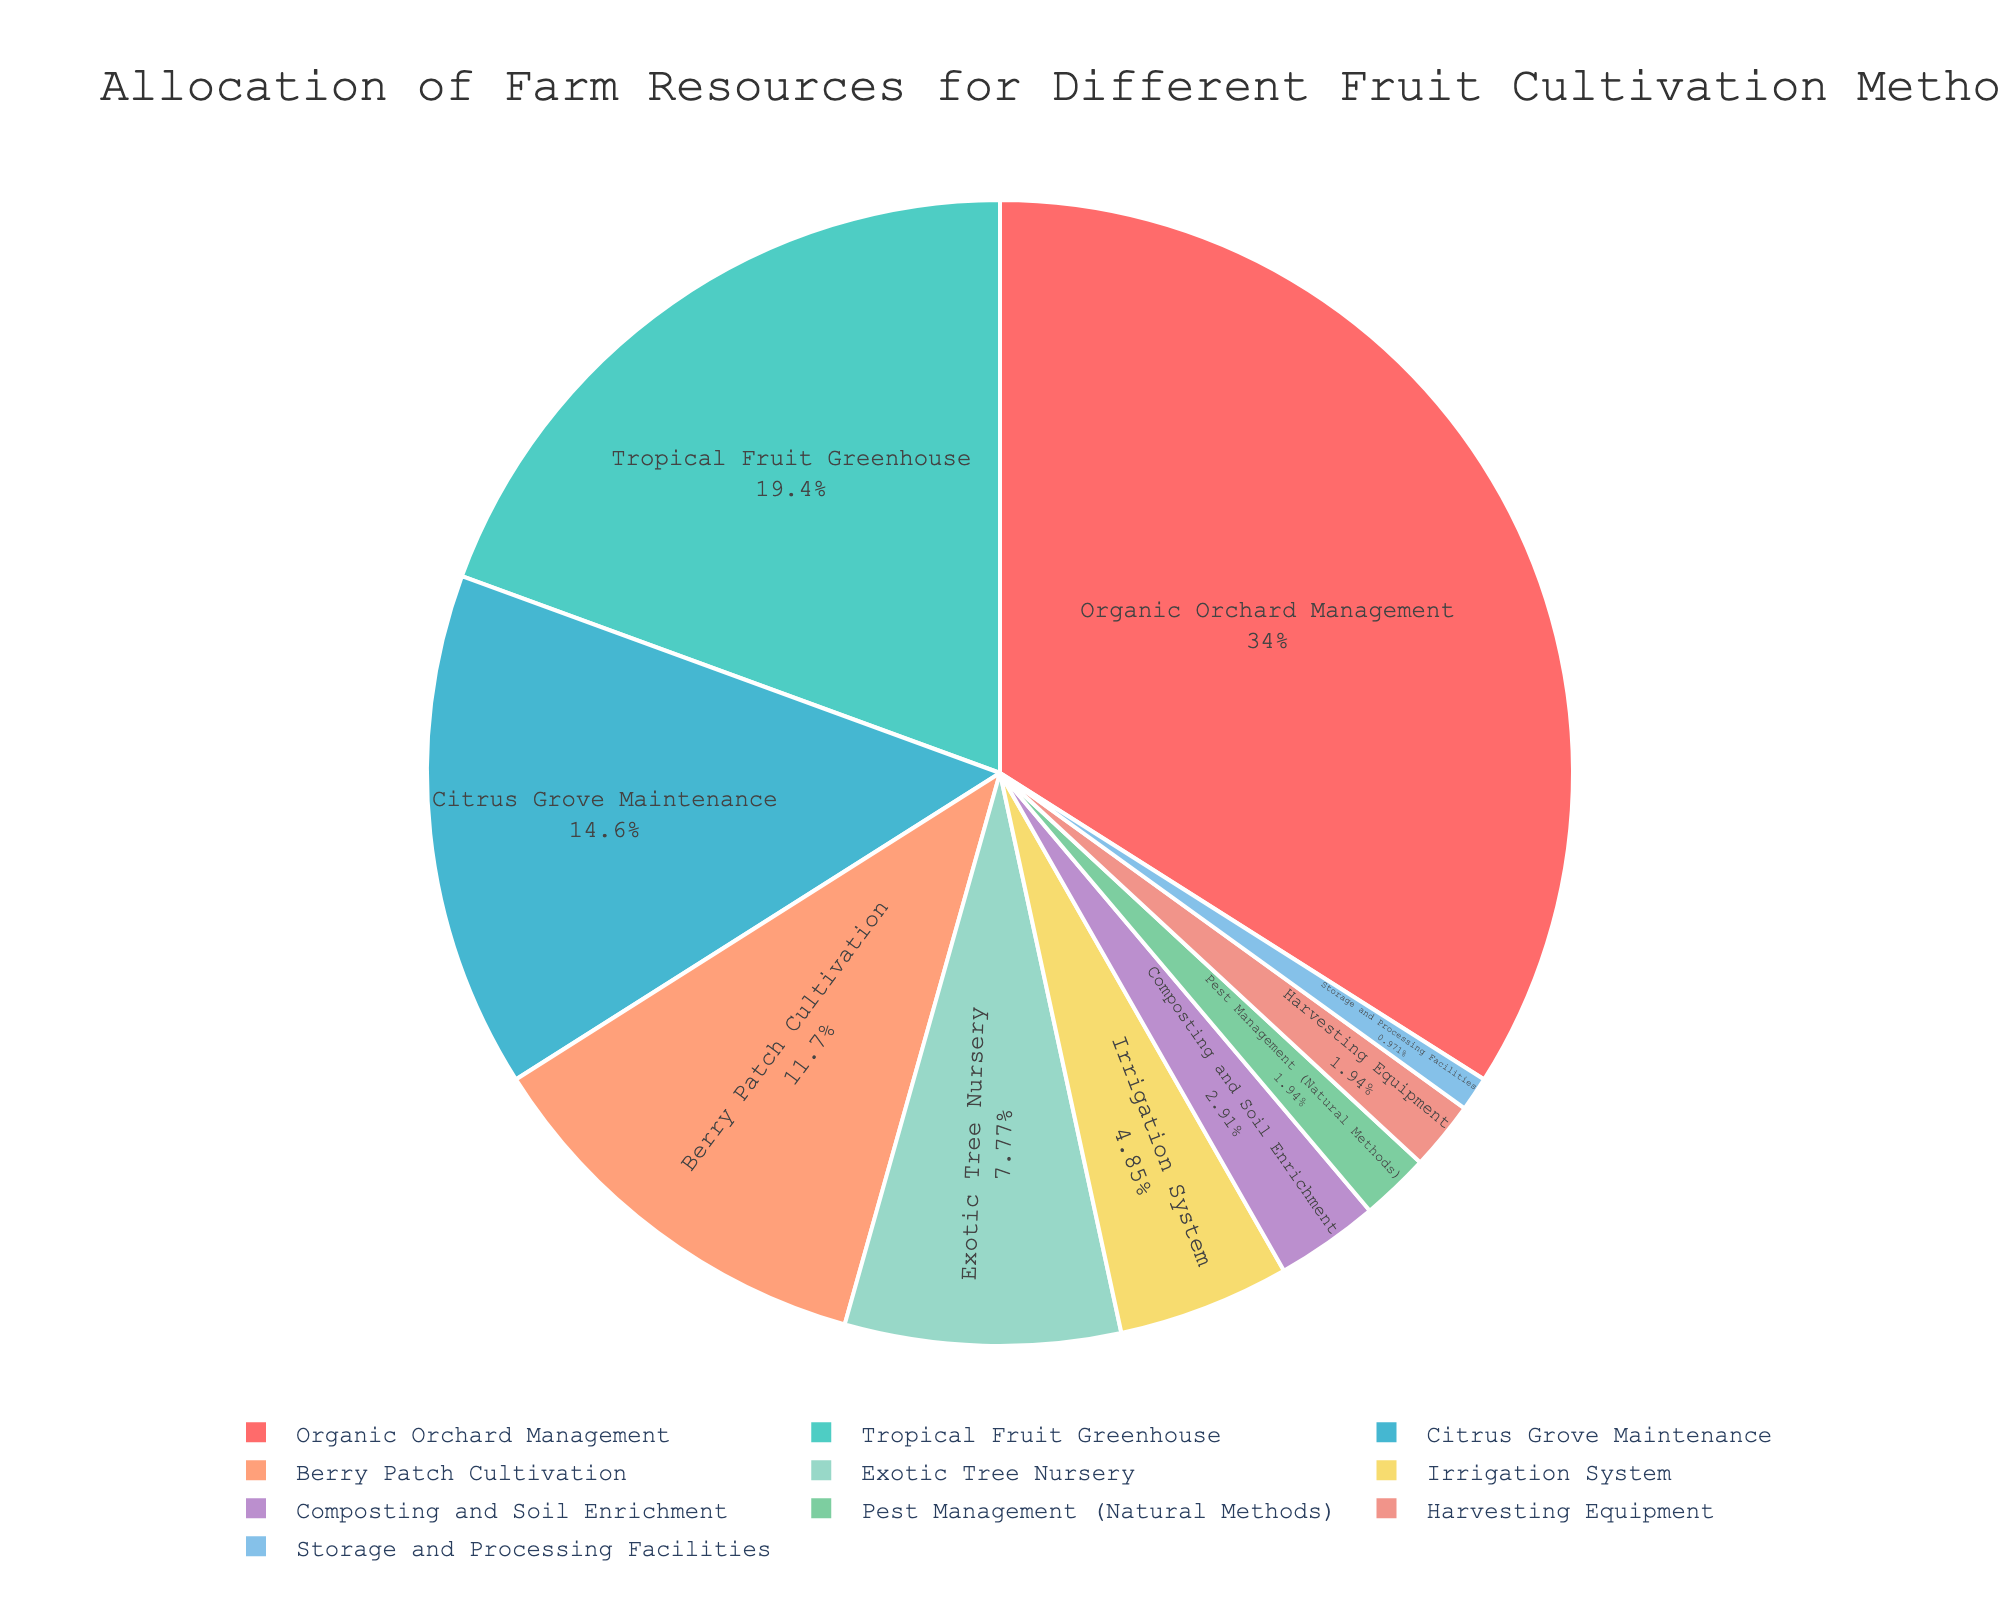What percentage of resources is allocated to the Tropical Fruit Greenhouse and Citrus Grove Maintenance combined? To get the combined percentage, you add the Tropical Fruit Greenhouse percentage (20%) and the Citrus Grove Maintenance percentage (15%). Therefore, 20% + 15% = 35%.
Answer: 35% What is the smallest percentage allocation, and to which resource does it belong? The smallest percentage allocation is 1%, which is allocated to Storage and Processing Facilities.
Answer: 1%, Storage and Processing Facilities Which resource has a higher allocation: Berry Patch Cultivation or Irrigation System? By checking the chart, Berry Patch Cultivation has 12%, whereas the Irrigation System has 5%. Thus, Berry Patch Cultivation has a higher allocation.
Answer: Berry Patch Cultivation How much greater is the percentage allocated to Organic Orchard Management than to Composting and Soil Enrichment? Organic Orchard Management is allocated 35%, and Composting and Soil Enrichment is allocated 3%. Subtracting these, 35% - 3% = 32%.
Answer: 32% Which resource is allocated more: Exotic Tree Nursery or Pest Management (Natural Methods)? Comparing the percentages, Exotic Tree Nursery has 8%, whereas Pest Management (Natural Methods) has 2%. Hence, Exotic Tree Nursery is allocated more.
Answer: Exotic Tree Nursery What is the average allocation percentage of Irrigation System and Harvesting Equipment? The allocation for Irrigation System is 5%, and for Harvesting Equipment, it is 2%. The average is calculated by (5% + 2%) / 2 = 3.5%.
Answer: 3.5% Which slice in the pie chart is visually the largest? Based on the percentages shown in the pie chart, the largest slice is for Organic Orchard Management, which is 35%.
Answer: Organic Orchard Management Is the allocation for Citrus Grove Maintenance greater than, less than, or equal to the combined allocation of Pest Management (Natural Methods) and Harvesting Equipment? Citrus Grove Maintenance is 15%. The combined allocation for Pest Management (Natural Methods) and Harvesting Equipment is 2% + 2% = 4%. Hence, 15% is greater than 4%.
Answer: Greater What is the second smallest allocation in the pie chart? The second smallest allocation is 2%, which is allocated to both Pest Management (Natural Methods) and Harvesting Equipment.
Answer: 2% What percentage of the total allocation is dedicated to maintenance-oriented resources (considering Organic Orchard Management, Tropical Fruit Greenhouse, and Citrus Grove Maintenance)? The total allocation for these resources is found by adding their percentages: Organic Orchard Management (35%), Tropical Fruit Greenhouse (20%), and Citrus Grove Maintenance (15%). Thus, 35% + 20% + 15% = 70%.
Answer: 70% 